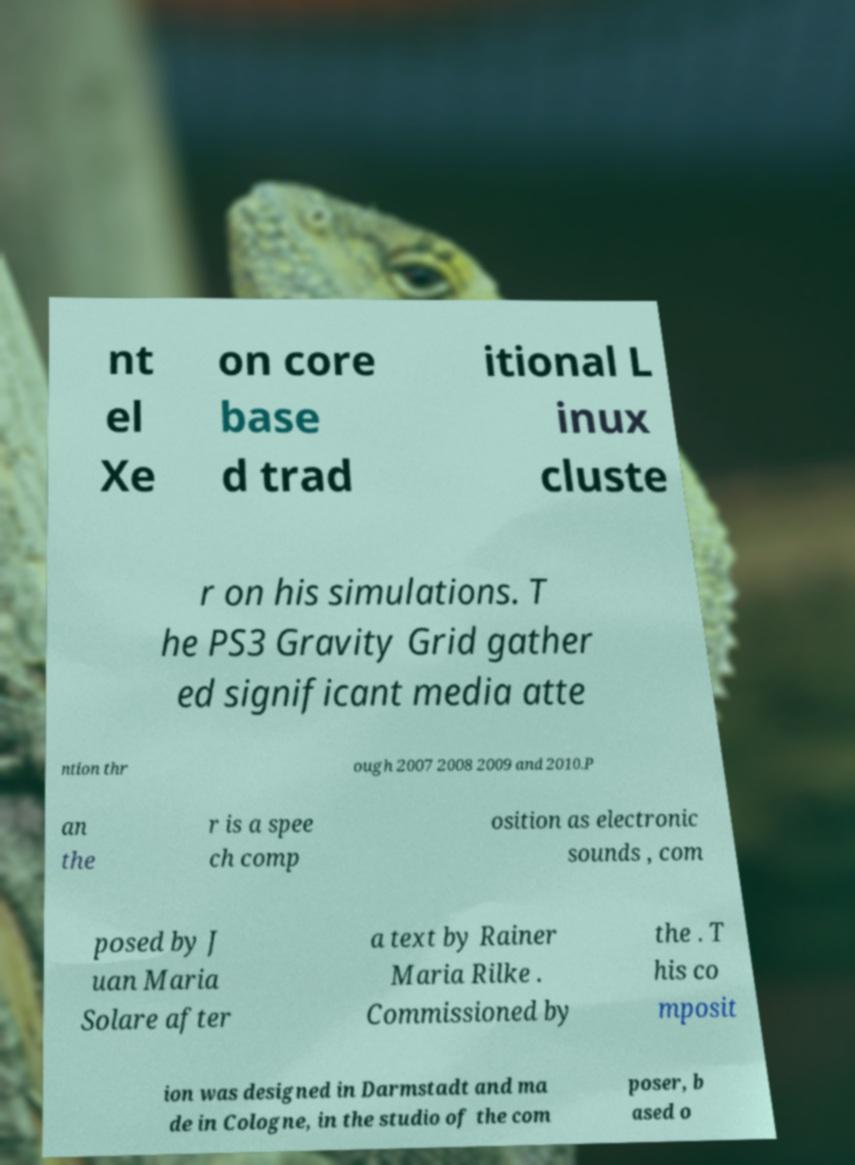Could you assist in decoding the text presented in this image and type it out clearly? nt el Xe on core base d trad itional L inux cluste r on his simulations. T he PS3 Gravity Grid gather ed significant media atte ntion thr ough 2007 2008 2009 and 2010.P an the r is a spee ch comp osition as electronic sounds , com posed by J uan Maria Solare after a text by Rainer Maria Rilke . Commissioned by the . T his co mposit ion was designed in Darmstadt and ma de in Cologne, in the studio of the com poser, b ased o 